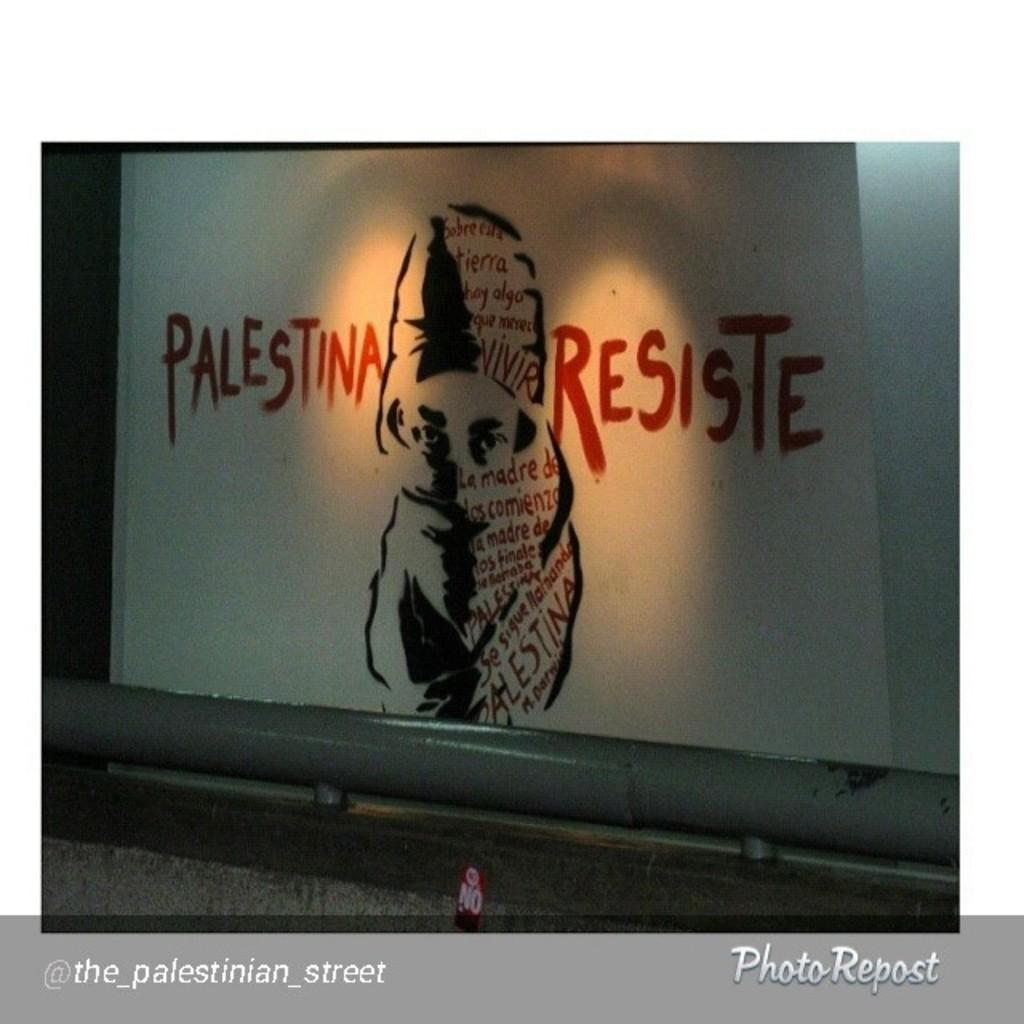What is the main object in the image? There is a white projector screen in the image. What is happening on the projector screen? A woman is on the screen, covering her face with a cloth. Is there any text on the screen? Yes, a slogan is written on the screen. What type of yarn is the woman using to cover her face in the image? There is no yarn present in the image; the woman is using a cloth to cover her face. 